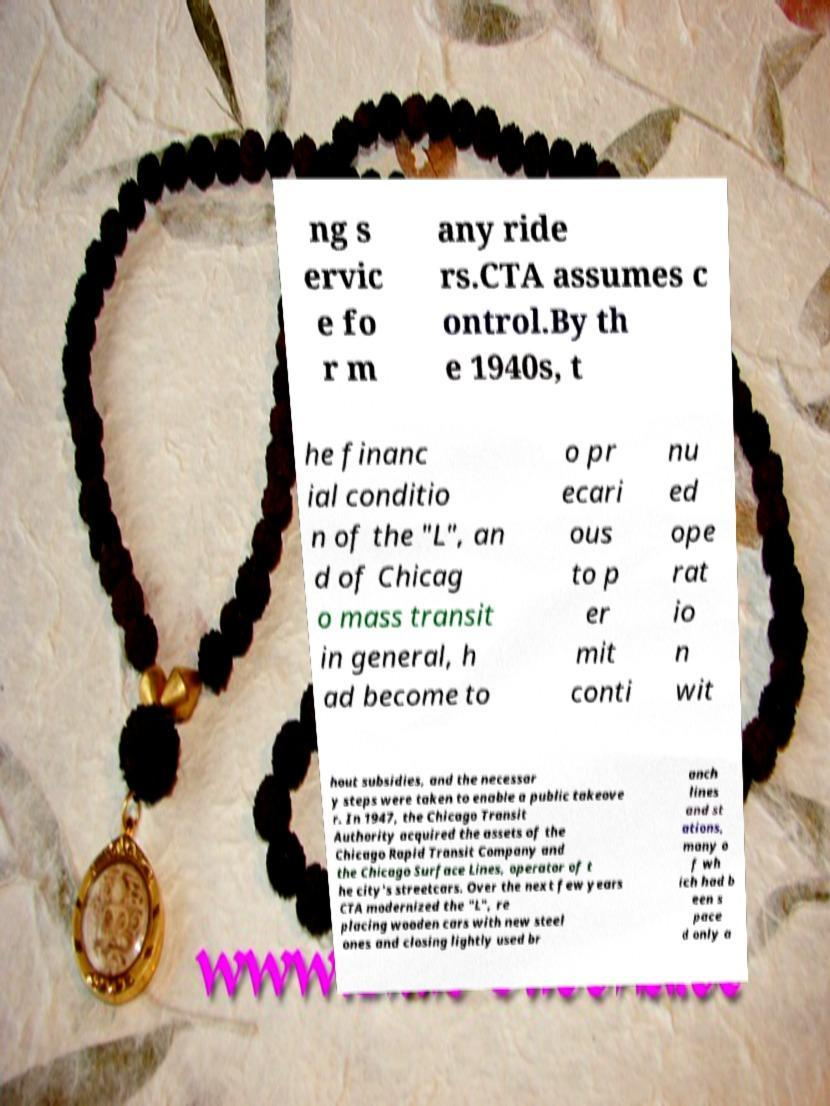Please read and relay the text visible in this image. What does it say? ng s ervic e fo r m any ride rs.CTA assumes c ontrol.By th e 1940s, t he financ ial conditio n of the "L", an d of Chicag o mass transit in general, h ad become to o pr ecari ous to p er mit conti nu ed ope rat io n wit hout subsidies, and the necessar y steps were taken to enable a public takeove r. In 1947, the Chicago Transit Authority acquired the assets of the Chicago Rapid Transit Company and the Chicago Surface Lines, operator of t he city's streetcars. Over the next few years CTA modernized the "L", re placing wooden cars with new steel ones and closing lightly used br anch lines and st ations, many o f wh ich had b een s pace d only a 